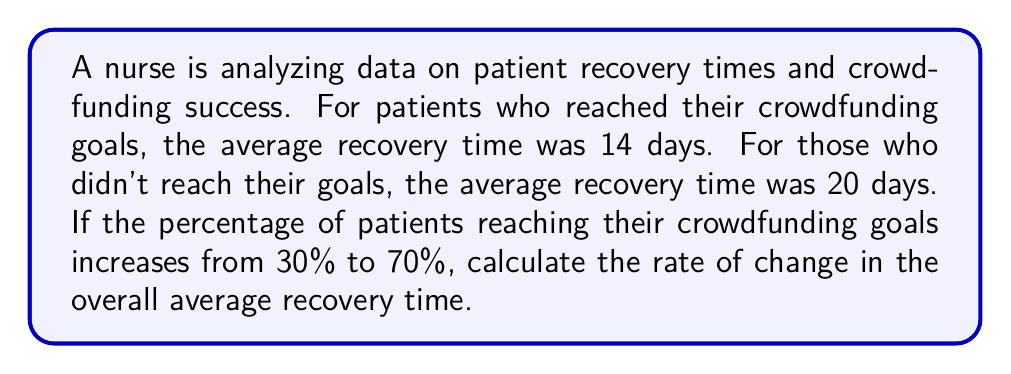Solve this math problem. Let's approach this step-by-step:

1) First, let's define our variables:
   $x$ = percentage of patients reaching crowdfunding goals
   $y$ = average recovery time in days

2) We can create a linear equation to represent the relationship:
   $y = 20 - 6(\frac{x}{100})$

   This is because:
   - When $x = 0$, $y = 20$ (all patients don't reach their goals)
   - When $x = 100$, $y = 14$ (all patients reach their goals)

3) To find the rate of change, we need to calculate the slope of this line:

   $\text{slope} = \frac{\Delta y}{\Delta x} = \frac{y_2 - y_1}{x_2 - x_1}$

4) Let's calculate $y$ for $x = 30$ and $x = 70$:

   When $x = 30$: $y = 20 - 6(\frac{30}{100}) = 20 - 1.8 = 18.2$
   When $x = 70$: $y = 20 - 6(\frac{70}{100}) = 20 - 4.2 = 15.8$

5) Now we can calculate the slope:

   $\text{slope} = \frac{15.8 - 18.2}{70 - 30} = \frac{-2.4}{40} = -0.06$

6) The negative sign indicates that as the percentage of patients reaching their crowdfunding goals increases, the average recovery time decreases.
Answer: $-0.06$ days per percentage point 